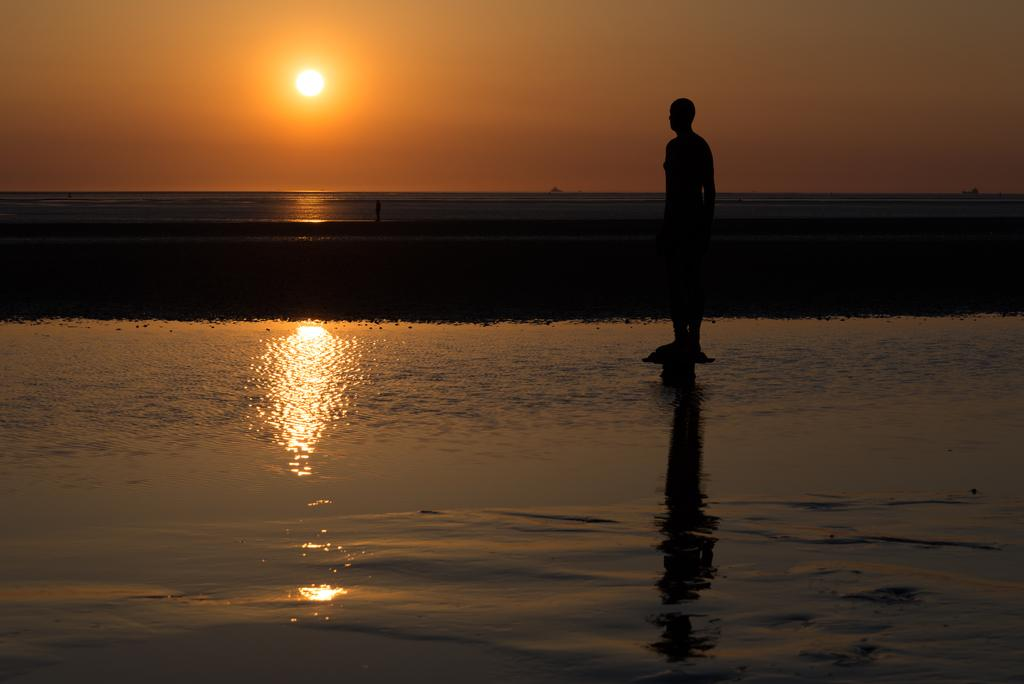What is the main subject of the image? There is a person standing in the center of the image. What can be seen in the background of the image? The sky, the sun, and water are visible in the background of the image. How many sticks are visible in the image? There are no sticks present in the image. 